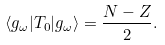Convert formula to latex. <formula><loc_0><loc_0><loc_500><loc_500>\langle g _ { \omega } | T _ { 0 } | g _ { \omega } \rangle = \frac { N - Z } { 2 } .</formula> 